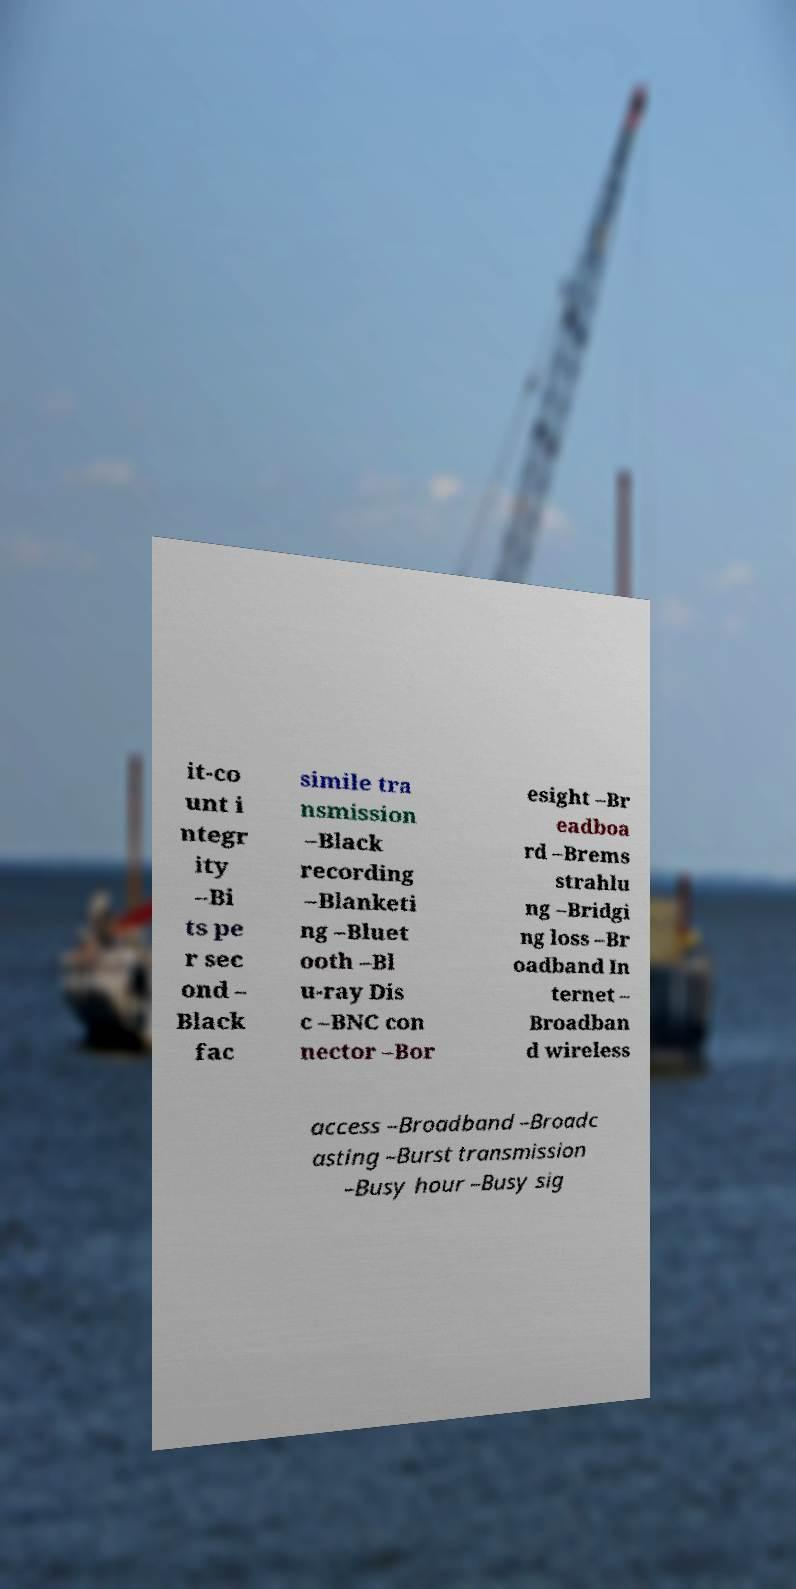Can you read and provide the text displayed in the image?This photo seems to have some interesting text. Can you extract and type it out for me? it-co unt i ntegr ity –Bi ts pe r sec ond – Black fac simile tra nsmission –Black recording –Blanketi ng –Bluet ooth –Bl u-ray Dis c –BNC con nector –Bor esight –Br eadboa rd –Brems strahlu ng –Bridgi ng loss –Br oadband In ternet – Broadban d wireless access –Broadband –Broadc asting –Burst transmission –Busy hour –Busy sig 